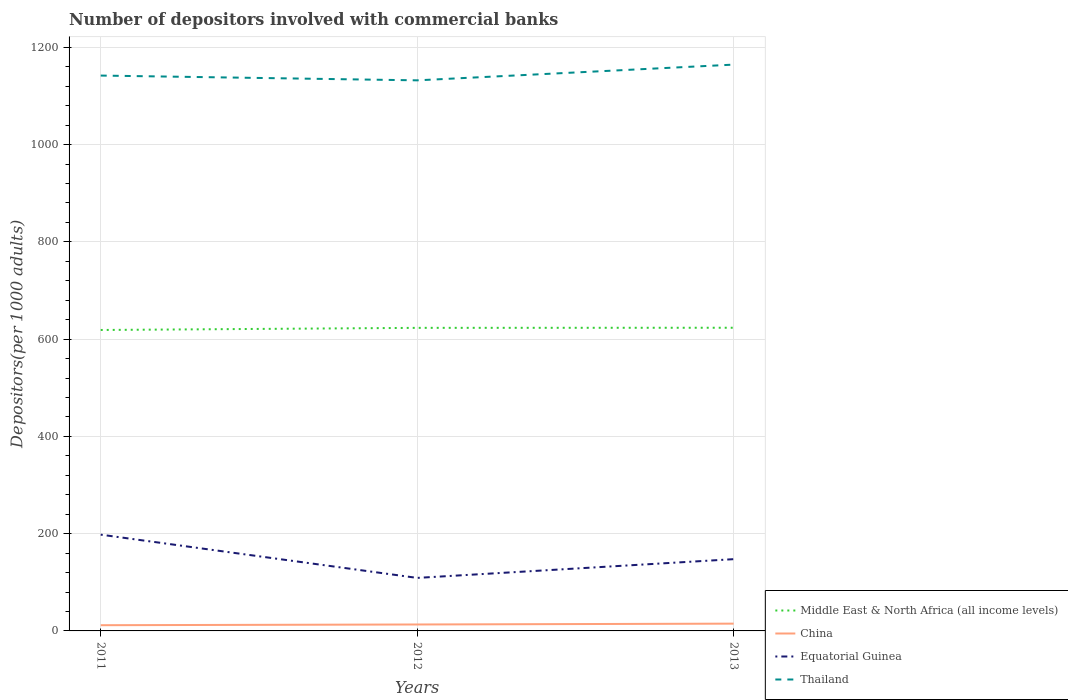How many different coloured lines are there?
Offer a terse response. 4. Across all years, what is the maximum number of depositors involved with commercial banks in China?
Your response must be concise. 11.75. In which year was the number of depositors involved with commercial banks in Equatorial Guinea maximum?
Provide a short and direct response. 2012. What is the total number of depositors involved with commercial banks in Thailand in the graph?
Give a very brief answer. -22.53. What is the difference between the highest and the second highest number of depositors involved with commercial banks in Middle East & North Africa (all income levels)?
Provide a succinct answer. 4.61. What is the difference between the highest and the lowest number of depositors involved with commercial banks in Equatorial Guinea?
Make the answer very short. 1. Is the number of depositors involved with commercial banks in China strictly greater than the number of depositors involved with commercial banks in Middle East & North Africa (all income levels) over the years?
Provide a short and direct response. Yes. How many lines are there?
Make the answer very short. 4. Are the values on the major ticks of Y-axis written in scientific E-notation?
Offer a very short reply. No. Does the graph contain grids?
Offer a terse response. Yes. Where does the legend appear in the graph?
Offer a very short reply. Bottom right. How many legend labels are there?
Keep it short and to the point. 4. How are the legend labels stacked?
Offer a very short reply. Vertical. What is the title of the graph?
Provide a succinct answer. Number of depositors involved with commercial banks. What is the label or title of the X-axis?
Offer a very short reply. Years. What is the label or title of the Y-axis?
Your answer should be compact. Depositors(per 1000 adults). What is the Depositors(per 1000 adults) in Middle East & North Africa (all income levels) in 2011?
Ensure brevity in your answer.  618.84. What is the Depositors(per 1000 adults) in China in 2011?
Your answer should be compact. 11.75. What is the Depositors(per 1000 adults) in Equatorial Guinea in 2011?
Your response must be concise. 197.96. What is the Depositors(per 1000 adults) of Thailand in 2011?
Offer a very short reply. 1142.03. What is the Depositors(per 1000 adults) in Middle East & North Africa (all income levels) in 2012?
Keep it short and to the point. 623.22. What is the Depositors(per 1000 adults) of China in 2012?
Your answer should be very brief. 13.23. What is the Depositors(per 1000 adults) in Equatorial Guinea in 2012?
Make the answer very short. 109.02. What is the Depositors(per 1000 adults) of Thailand in 2012?
Make the answer very short. 1132.21. What is the Depositors(per 1000 adults) of Middle East & North Africa (all income levels) in 2013?
Offer a very short reply. 623.45. What is the Depositors(per 1000 adults) in China in 2013?
Your answer should be compact. 14.96. What is the Depositors(per 1000 adults) in Equatorial Guinea in 2013?
Keep it short and to the point. 147.57. What is the Depositors(per 1000 adults) in Thailand in 2013?
Give a very brief answer. 1164.56. Across all years, what is the maximum Depositors(per 1000 adults) in Middle East & North Africa (all income levels)?
Offer a very short reply. 623.45. Across all years, what is the maximum Depositors(per 1000 adults) in China?
Ensure brevity in your answer.  14.96. Across all years, what is the maximum Depositors(per 1000 adults) of Equatorial Guinea?
Keep it short and to the point. 197.96. Across all years, what is the maximum Depositors(per 1000 adults) in Thailand?
Give a very brief answer. 1164.56. Across all years, what is the minimum Depositors(per 1000 adults) of Middle East & North Africa (all income levels)?
Your answer should be very brief. 618.84. Across all years, what is the minimum Depositors(per 1000 adults) of China?
Your answer should be very brief. 11.75. Across all years, what is the minimum Depositors(per 1000 adults) in Equatorial Guinea?
Your response must be concise. 109.02. Across all years, what is the minimum Depositors(per 1000 adults) in Thailand?
Ensure brevity in your answer.  1132.21. What is the total Depositors(per 1000 adults) of Middle East & North Africa (all income levels) in the graph?
Provide a short and direct response. 1865.51. What is the total Depositors(per 1000 adults) in China in the graph?
Make the answer very short. 39.94. What is the total Depositors(per 1000 adults) in Equatorial Guinea in the graph?
Ensure brevity in your answer.  454.55. What is the total Depositors(per 1000 adults) of Thailand in the graph?
Ensure brevity in your answer.  3438.79. What is the difference between the Depositors(per 1000 adults) of Middle East & North Africa (all income levels) in 2011 and that in 2012?
Your answer should be compact. -4.38. What is the difference between the Depositors(per 1000 adults) of China in 2011 and that in 2012?
Your response must be concise. -1.48. What is the difference between the Depositors(per 1000 adults) in Equatorial Guinea in 2011 and that in 2012?
Your answer should be compact. 88.94. What is the difference between the Depositors(per 1000 adults) in Thailand in 2011 and that in 2012?
Your answer should be compact. 9.82. What is the difference between the Depositors(per 1000 adults) of Middle East & North Africa (all income levels) in 2011 and that in 2013?
Offer a terse response. -4.61. What is the difference between the Depositors(per 1000 adults) in China in 2011 and that in 2013?
Keep it short and to the point. -3.21. What is the difference between the Depositors(per 1000 adults) in Equatorial Guinea in 2011 and that in 2013?
Your response must be concise. 50.39. What is the difference between the Depositors(per 1000 adults) of Thailand in 2011 and that in 2013?
Offer a terse response. -22.53. What is the difference between the Depositors(per 1000 adults) in Middle East & North Africa (all income levels) in 2012 and that in 2013?
Offer a terse response. -0.23. What is the difference between the Depositors(per 1000 adults) of China in 2012 and that in 2013?
Offer a terse response. -1.73. What is the difference between the Depositors(per 1000 adults) in Equatorial Guinea in 2012 and that in 2013?
Make the answer very short. -38.55. What is the difference between the Depositors(per 1000 adults) of Thailand in 2012 and that in 2013?
Make the answer very short. -32.35. What is the difference between the Depositors(per 1000 adults) of Middle East & North Africa (all income levels) in 2011 and the Depositors(per 1000 adults) of China in 2012?
Your answer should be compact. 605.61. What is the difference between the Depositors(per 1000 adults) in Middle East & North Africa (all income levels) in 2011 and the Depositors(per 1000 adults) in Equatorial Guinea in 2012?
Provide a succinct answer. 509.82. What is the difference between the Depositors(per 1000 adults) of Middle East & North Africa (all income levels) in 2011 and the Depositors(per 1000 adults) of Thailand in 2012?
Provide a succinct answer. -513.36. What is the difference between the Depositors(per 1000 adults) in China in 2011 and the Depositors(per 1000 adults) in Equatorial Guinea in 2012?
Your response must be concise. -97.27. What is the difference between the Depositors(per 1000 adults) in China in 2011 and the Depositors(per 1000 adults) in Thailand in 2012?
Offer a very short reply. -1120.46. What is the difference between the Depositors(per 1000 adults) of Equatorial Guinea in 2011 and the Depositors(per 1000 adults) of Thailand in 2012?
Offer a terse response. -934.24. What is the difference between the Depositors(per 1000 adults) in Middle East & North Africa (all income levels) in 2011 and the Depositors(per 1000 adults) in China in 2013?
Make the answer very short. 603.88. What is the difference between the Depositors(per 1000 adults) in Middle East & North Africa (all income levels) in 2011 and the Depositors(per 1000 adults) in Equatorial Guinea in 2013?
Your response must be concise. 471.27. What is the difference between the Depositors(per 1000 adults) of Middle East & North Africa (all income levels) in 2011 and the Depositors(per 1000 adults) of Thailand in 2013?
Offer a very short reply. -545.72. What is the difference between the Depositors(per 1000 adults) in China in 2011 and the Depositors(per 1000 adults) in Equatorial Guinea in 2013?
Keep it short and to the point. -135.82. What is the difference between the Depositors(per 1000 adults) of China in 2011 and the Depositors(per 1000 adults) of Thailand in 2013?
Provide a short and direct response. -1152.81. What is the difference between the Depositors(per 1000 adults) of Equatorial Guinea in 2011 and the Depositors(per 1000 adults) of Thailand in 2013?
Provide a short and direct response. -966.6. What is the difference between the Depositors(per 1000 adults) in Middle East & North Africa (all income levels) in 2012 and the Depositors(per 1000 adults) in China in 2013?
Offer a very short reply. 608.26. What is the difference between the Depositors(per 1000 adults) in Middle East & North Africa (all income levels) in 2012 and the Depositors(per 1000 adults) in Equatorial Guinea in 2013?
Provide a succinct answer. 475.65. What is the difference between the Depositors(per 1000 adults) in Middle East & North Africa (all income levels) in 2012 and the Depositors(per 1000 adults) in Thailand in 2013?
Your answer should be compact. -541.34. What is the difference between the Depositors(per 1000 adults) in China in 2012 and the Depositors(per 1000 adults) in Equatorial Guinea in 2013?
Offer a terse response. -134.34. What is the difference between the Depositors(per 1000 adults) of China in 2012 and the Depositors(per 1000 adults) of Thailand in 2013?
Your response must be concise. -1151.32. What is the difference between the Depositors(per 1000 adults) in Equatorial Guinea in 2012 and the Depositors(per 1000 adults) in Thailand in 2013?
Ensure brevity in your answer.  -1055.54. What is the average Depositors(per 1000 adults) in Middle East & North Africa (all income levels) per year?
Your answer should be compact. 621.84. What is the average Depositors(per 1000 adults) of China per year?
Your answer should be very brief. 13.31. What is the average Depositors(per 1000 adults) in Equatorial Guinea per year?
Ensure brevity in your answer.  151.52. What is the average Depositors(per 1000 adults) of Thailand per year?
Offer a terse response. 1146.26. In the year 2011, what is the difference between the Depositors(per 1000 adults) in Middle East & North Africa (all income levels) and Depositors(per 1000 adults) in China?
Your answer should be very brief. 607.09. In the year 2011, what is the difference between the Depositors(per 1000 adults) in Middle East & North Africa (all income levels) and Depositors(per 1000 adults) in Equatorial Guinea?
Offer a terse response. 420.88. In the year 2011, what is the difference between the Depositors(per 1000 adults) of Middle East & North Africa (all income levels) and Depositors(per 1000 adults) of Thailand?
Ensure brevity in your answer.  -523.18. In the year 2011, what is the difference between the Depositors(per 1000 adults) of China and Depositors(per 1000 adults) of Equatorial Guinea?
Make the answer very short. -186.21. In the year 2011, what is the difference between the Depositors(per 1000 adults) in China and Depositors(per 1000 adults) in Thailand?
Keep it short and to the point. -1130.27. In the year 2011, what is the difference between the Depositors(per 1000 adults) in Equatorial Guinea and Depositors(per 1000 adults) in Thailand?
Make the answer very short. -944.06. In the year 2012, what is the difference between the Depositors(per 1000 adults) of Middle East & North Africa (all income levels) and Depositors(per 1000 adults) of China?
Your response must be concise. 609.99. In the year 2012, what is the difference between the Depositors(per 1000 adults) in Middle East & North Africa (all income levels) and Depositors(per 1000 adults) in Equatorial Guinea?
Offer a very short reply. 514.2. In the year 2012, what is the difference between the Depositors(per 1000 adults) in Middle East & North Africa (all income levels) and Depositors(per 1000 adults) in Thailand?
Make the answer very short. -508.98. In the year 2012, what is the difference between the Depositors(per 1000 adults) in China and Depositors(per 1000 adults) in Equatorial Guinea?
Your answer should be very brief. -95.79. In the year 2012, what is the difference between the Depositors(per 1000 adults) in China and Depositors(per 1000 adults) in Thailand?
Provide a short and direct response. -1118.97. In the year 2012, what is the difference between the Depositors(per 1000 adults) in Equatorial Guinea and Depositors(per 1000 adults) in Thailand?
Your answer should be compact. -1023.19. In the year 2013, what is the difference between the Depositors(per 1000 adults) in Middle East & North Africa (all income levels) and Depositors(per 1000 adults) in China?
Make the answer very short. 608.49. In the year 2013, what is the difference between the Depositors(per 1000 adults) in Middle East & North Africa (all income levels) and Depositors(per 1000 adults) in Equatorial Guinea?
Offer a terse response. 475.88. In the year 2013, what is the difference between the Depositors(per 1000 adults) in Middle East & North Africa (all income levels) and Depositors(per 1000 adults) in Thailand?
Give a very brief answer. -541.11. In the year 2013, what is the difference between the Depositors(per 1000 adults) of China and Depositors(per 1000 adults) of Equatorial Guinea?
Your response must be concise. -132.61. In the year 2013, what is the difference between the Depositors(per 1000 adults) of China and Depositors(per 1000 adults) of Thailand?
Keep it short and to the point. -1149.6. In the year 2013, what is the difference between the Depositors(per 1000 adults) of Equatorial Guinea and Depositors(per 1000 adults) of Thailand?
Ensure brevity in your answer.  -1016.99. What is the ratio of the Depositors(per 1000 adults) in Middle East & North Africa (all income levels) in 2011 to that in 2012?
Your answer should be compact. 0.99. What is the ratio of the Depositors(per 1000 adults) of China in 2011 to that in 2012?
Your response must be concise. 0.89. What is the ratio of the Depositors(per 1000 adults) of Equatorial Guinea in 2011 to that in 2012?
Your response must be concise. 1.82. What is the ratio of the Depositors(per 1000 adults) in Thailand in 2011 to that in 2012?
Make the answer very short. 1.01. What is the ratio of the Depositors(per 1000 adults) of China in 2011 to that in 2013?
Your answer should be very brief. 0.79. What is the ratio of the Depositors(per 1000 adults) of Equatorial Guinea in 2011 to that in 2013?
Provide a short and direct response. 1.34. What is the ratio of the Depositors(per 1000 adults) of Thailand in 2011 to that in 2013?
Offer a terse response. 0.98. What is the ratio of the Depositors(per 1000 adults) of China in 2012 to that in 2013?
Give a very brief answer. 0.88. What is the ratio of the Depositors(per 1000 adults) in Equatorial Guinea in 2012 to that in 2013?
Provide a succinct answer. 0.74. What is the ratio of the Depositors(per 1000 adults) of Thailand in 2012 to that in 2013?
Your response must be concise. 0.97. What is the difference between the highest and the second highest Depositors(per 1000 adults) of Middle East & North Africa (all income levels)?
Ensure brevity in your answer.  0.23. What is the difference between the highest and the second highest Depositors(per 1000 adults) in China?
Keep it short and to the point. 1.73. What is the difference between the highest and the second highest Depositors(per 1000 adults) of Equatorial Guinea?
Provide a succinct answer. 50.39. What is the difference between the highest and the second highest Depositors(per 1000 adults) in Thailand?
Offer a very short reply. 22.53. What is the difference between the highest and the lowest Depositors(per 1000 adults) in Middle East & North Africa (all income levels)?
Provide a short and direct response. 4.61. What is the difference between the highest and the lowest Depositors(per 1000 adults) of China?
Your answer should be compact. 3.21. What is the difference between the highest and the lowest Depositors(per 1000 adults) in Equatorial Guinea?
Keep it short and to the point. 88.94. What is the difference between the highest and the lowest Depositors(per 1000 adults) of Thailand?
Ensure brevity in your answer.  32.35. 